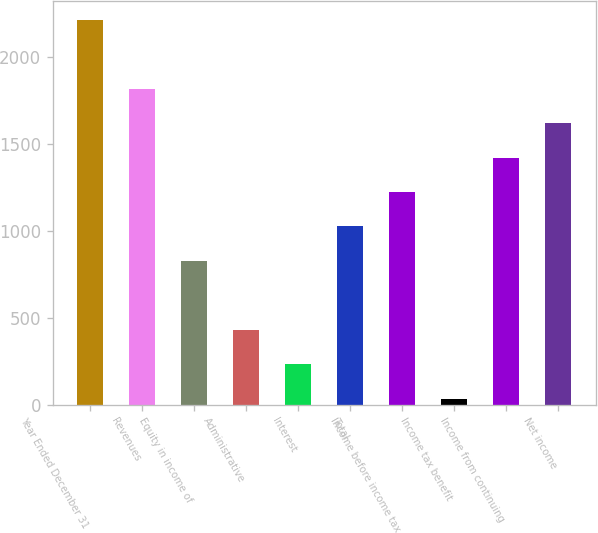<chart> <loc_0><loc_0><loc_500><loc_500><bar_chart><fcel>Year Ended December 31<fcel>Revenues<fcel>Equity in income of<fcel>Administrative<fcel>Interest<fcel>Total<fcel>Income before income tax<fcel>Income tax benefit<fcel>Income from continuing<fcel>Net income<nl><fcel>2214.3<fcel>1817.7<fcel>826.2<fcel>429.6<fcel>231.3<fcel>1024.5<fcel>1222.8<fcel>33<fcel>1421.1<fcel>1619.4<nl></chart> 